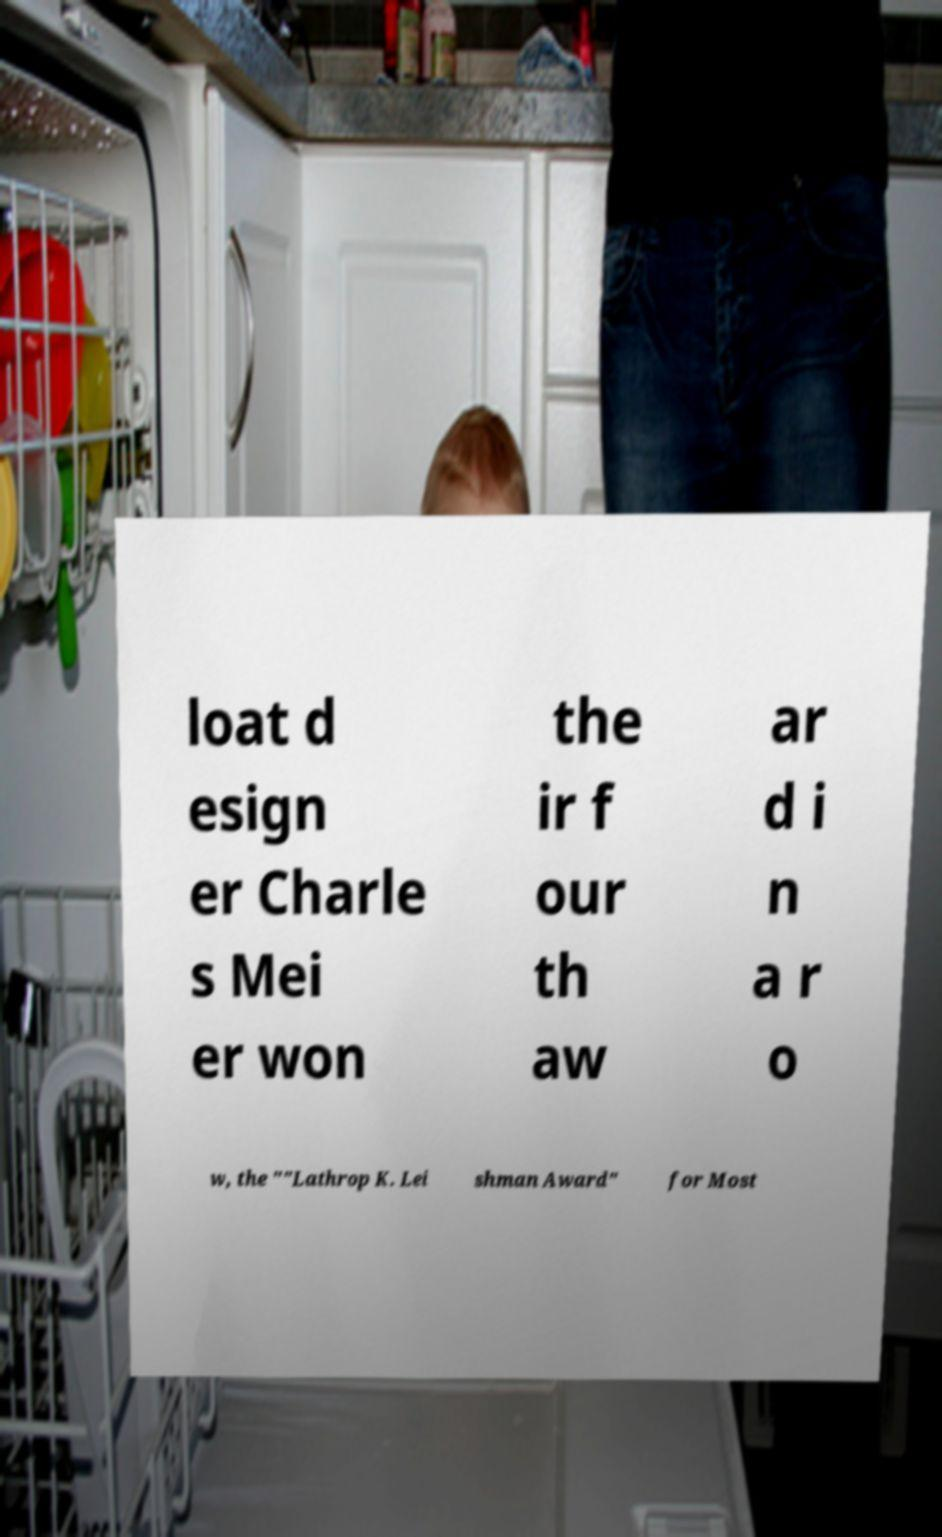Could you assist in decoding the text presented in this image and type it out clearly? loat d esign er Charle s Mei er won the ir f our th aw ar d i n a r o w, the ""Lathrop K. Lei shman Award" for Most 